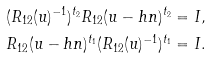Convert formula to latex. <formula><loc_0><loc_0><loc_500><loc_500>( R _ { 1 2 } ( u ) ^ { - 1 } ) ^ { t _ { 2 } } R _ { 1 2 } ( u - h n ) ^ { t _ { 2 } } & = I , \\ R _ { 1 2 } ( u - h n ) ^ { t _ { 1 } } ( R _ { 1 2 } ( u ) ^ { - 1 } ) ^ { t _ { 1 } } & = I .</formula> 